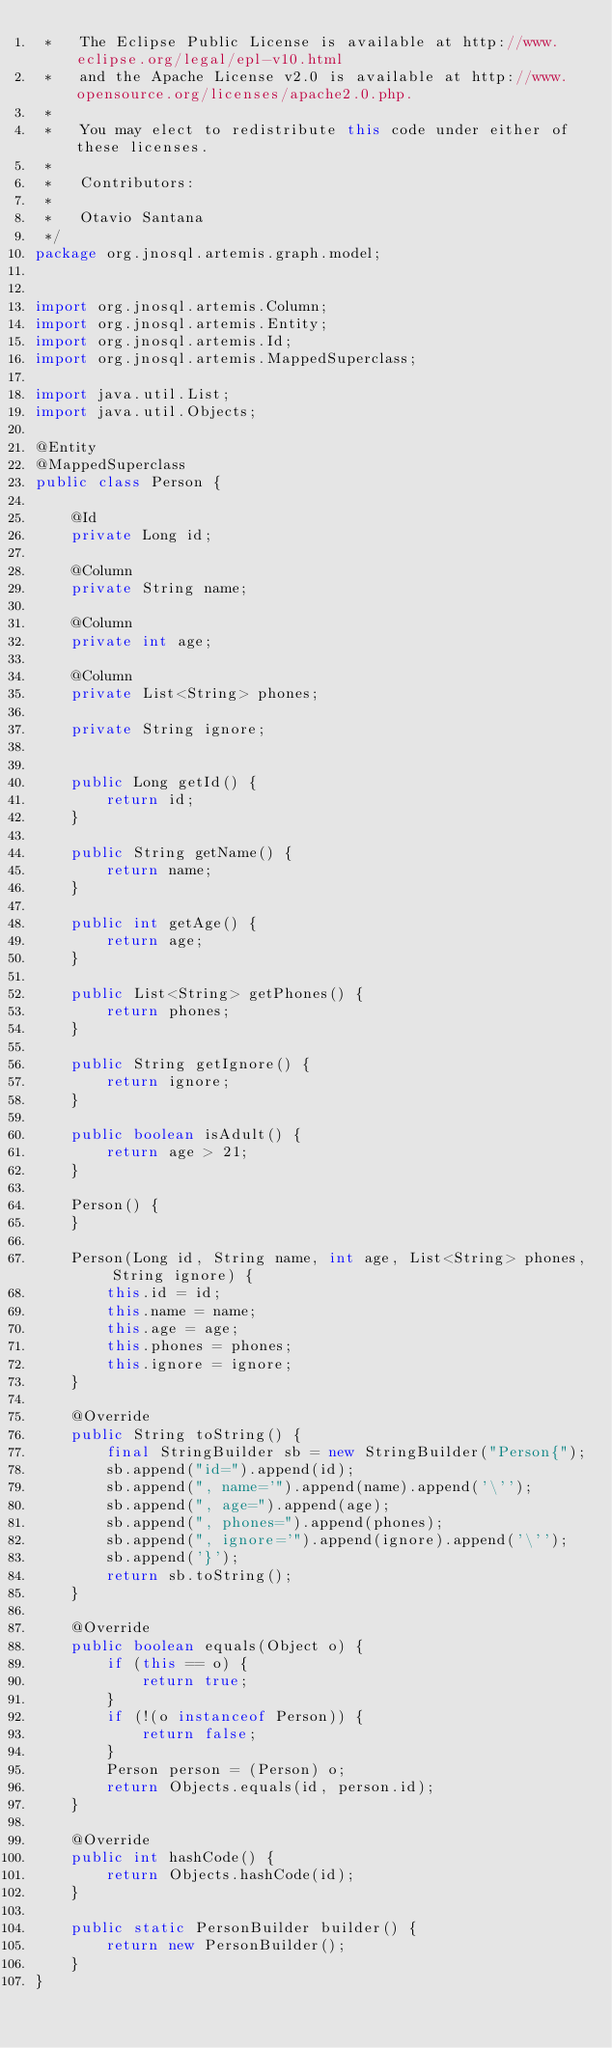Convert code to text. <code><loc_0><loc_0><loc_500><loc_500><_Java_> *   The Eclipse Public License is available at http://www.eclipse.org/legal/epl-v10.html
 *   and the Apache License v2.0 is available at http://www.opensource.org/licenses/apache2.0.php.
 *
 *   You may elect to redistribute this code under either of these licenses.
 *
 *   Contributors:
 *
 *   Otavio Santana
 */
package org.jnosql.artemis.graph.model;


import org.jnosql.artemis.Column;
import org.jnosql.artemis.Entity;
import org.jnosql.artemis.Id;
import org.jnosql.artemis.MappedSuperclass;

import java.util.List;
import java.util.Objects;

@Entity
@MappedSuperclass
public class Person {

    @Id
    private Long id;

    @Column
    private String name;

    @Column
    private int age;

    @Column
    private List<String> phones;

    private String ignore;


    public Long getId() {
        return id;
    }

    public String getName() {
        return name;
    }

    public int getAge() {
        return age;
    }

    public List<String> getPhones() {
        return phones;
    }

    public String getIgnore() {
        return ignore;
    }

    public boolean isAdult() {
        return age > 21;
    }

    Person() {
    }

    Person(Long id, String name, int age, List<String> phones, String ignore) {
        this.id = id;
        this.name = name;
        this.age = age;
        this.phones = phones;
        this.ignore = ignore;
    }

    @Override
    public String toString() {
        final StringBuilder sb = new StringBuilder("Person{");
        sb.append("id=").append(id);
        sb.append(", name='").append(name).append('\'');
        sb.append(", age=").append(age);
        sb.append(", phones=").append(phones);
        sb.append(", ignore='").append(ignore).append('\'');
        sb.append('}');
        return sb.toString();
    }

    @Override
    public boolean equals(Object o) {
        if (this == o) {
            return true;
        }
        if (!(o instanceof Person)) {
            return false;
        }
        Person person = (Person) o;
        return Objects.equals(id, person.id);
    }

    @Override
    public int hashCode() {
        return Objects.hashCode(id);
    }

    public static PersonBuilder builder() {
        return new PersonBuilder();
    }
}
</code> 